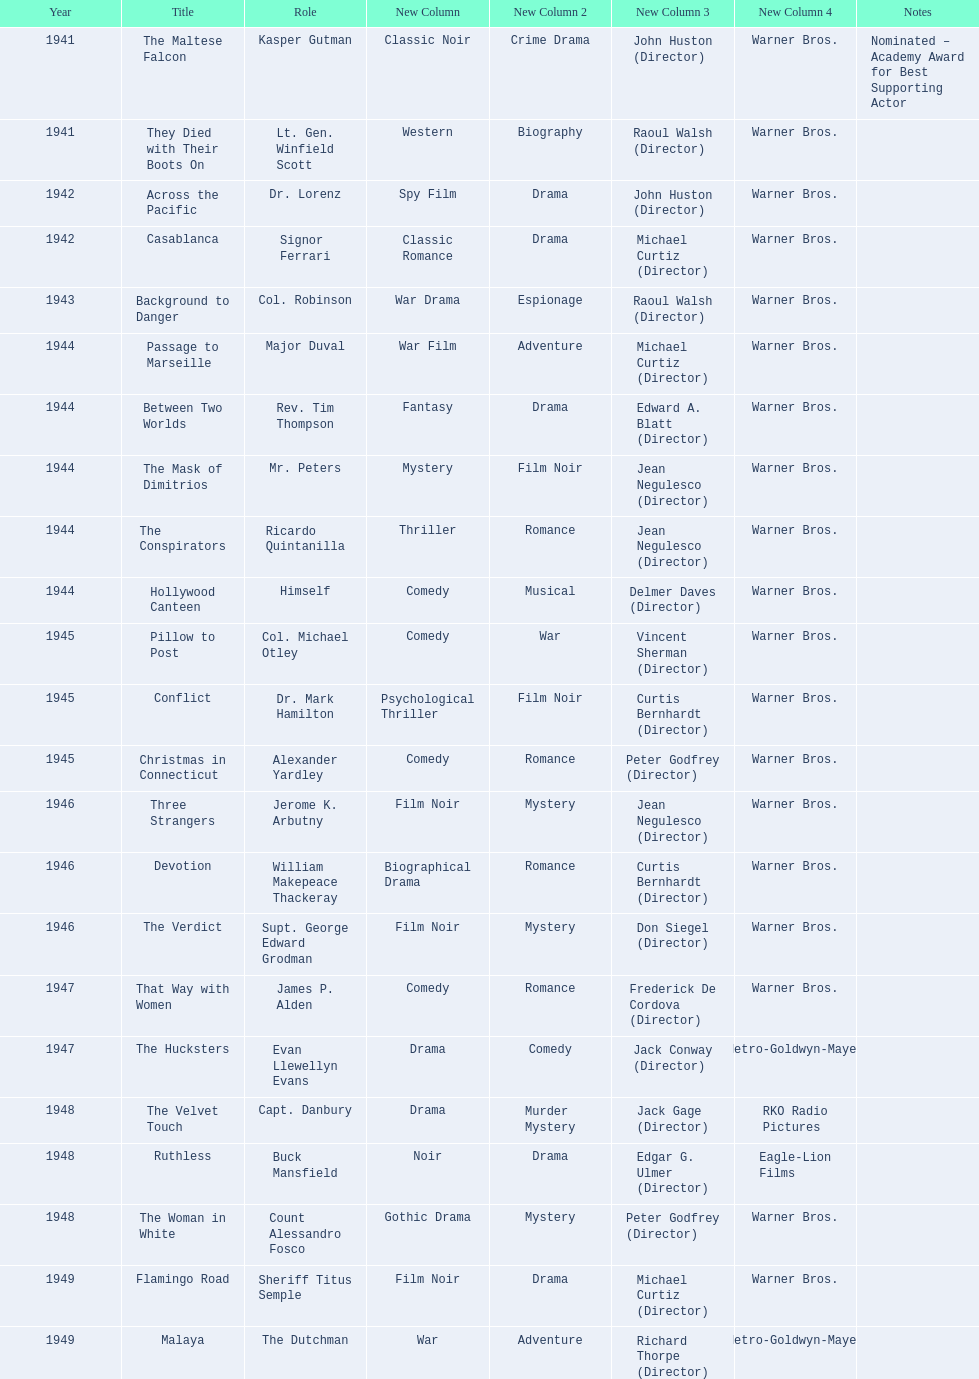Which movie did he get nominated for an oscar for? The Maltese Falcon. 